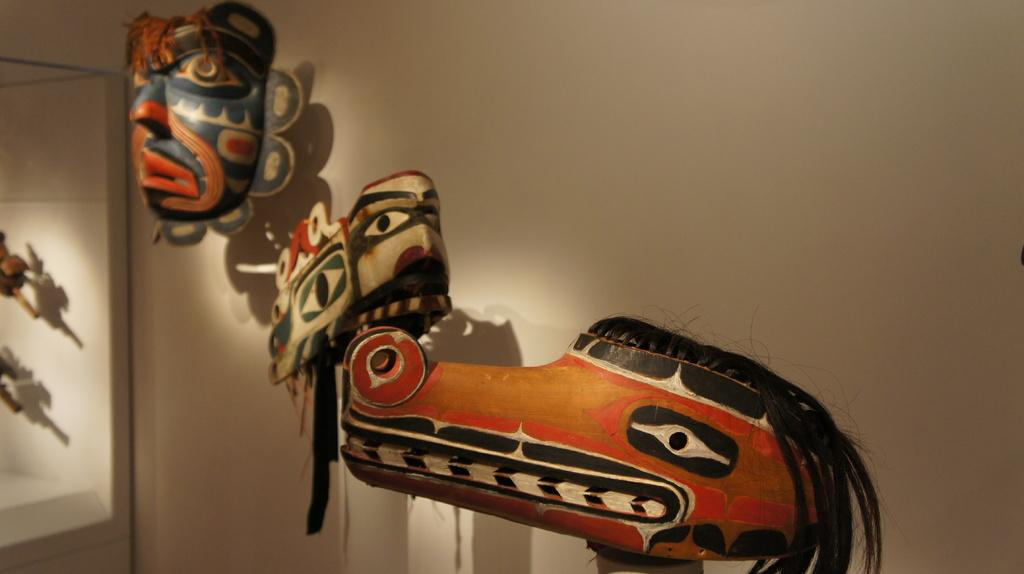What type of objects can be seen in the image? There are different masks in the image. Where are the masks located? The masks are attached to a wall. What material can be seen in the image besides the masks? There are wooden objects in the image. What type of pump is used to circulate the current in the image? There is no pump or current present in the image; it features different masks attached to a wall and wooden objects. Can you locate the heart in the image? There is no heart present in the image. 